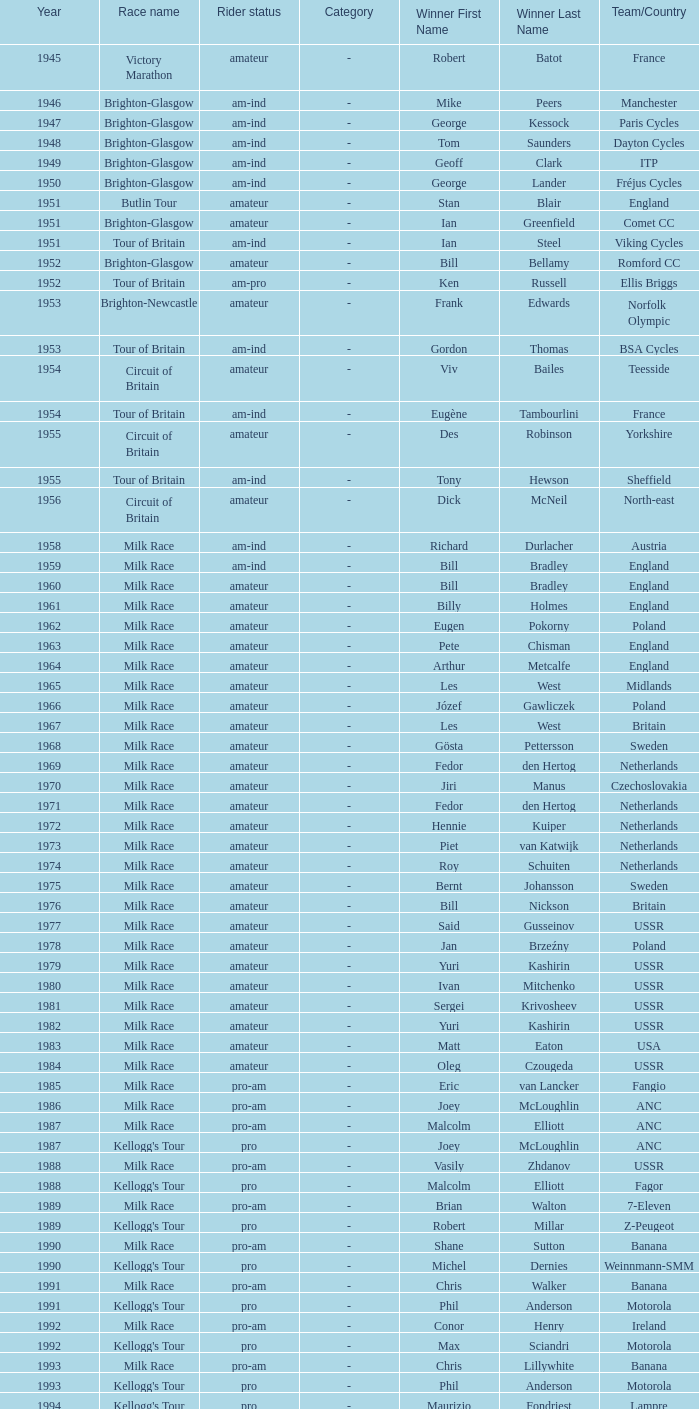What year marks phil anderson's most recent triumph? 1993.0. 